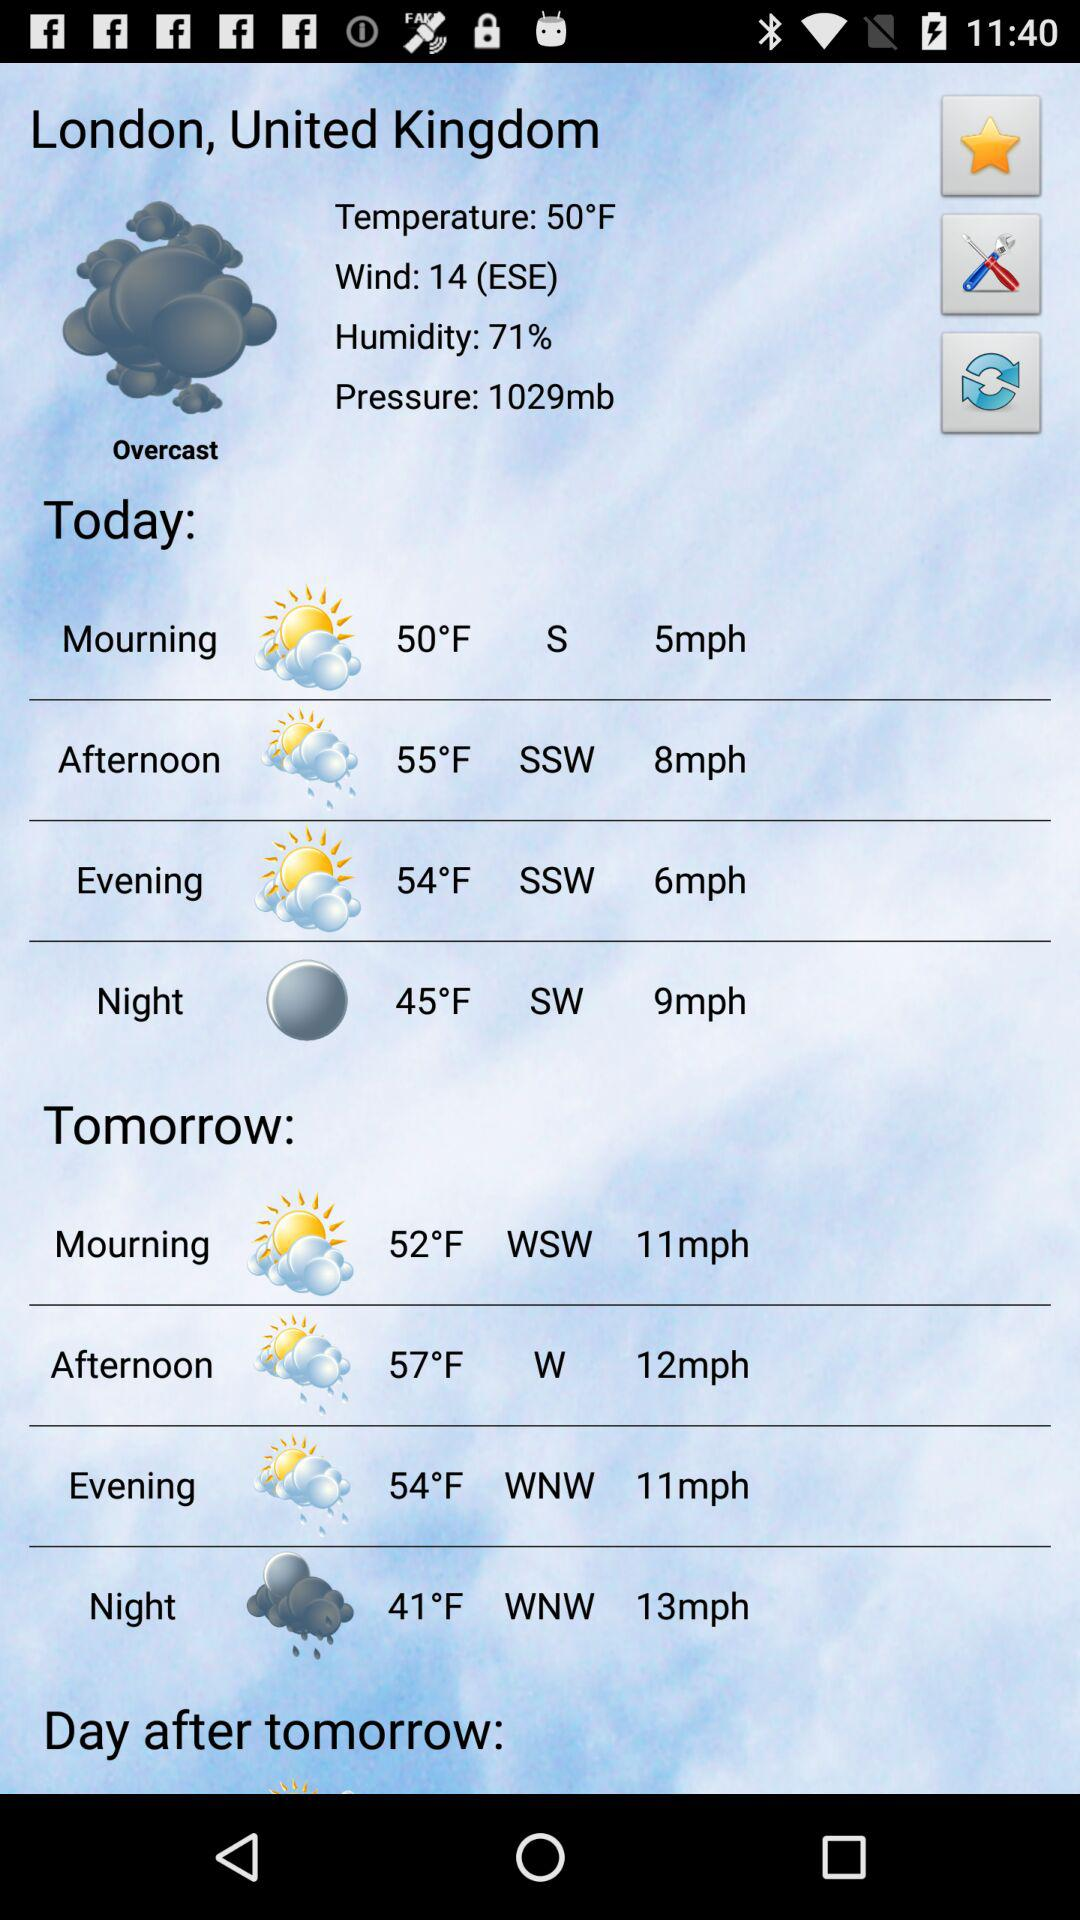What is the evening temperature in London, United Kingdom, today? Today's evening temperature in London, United Kingdom, is 54 °F. 